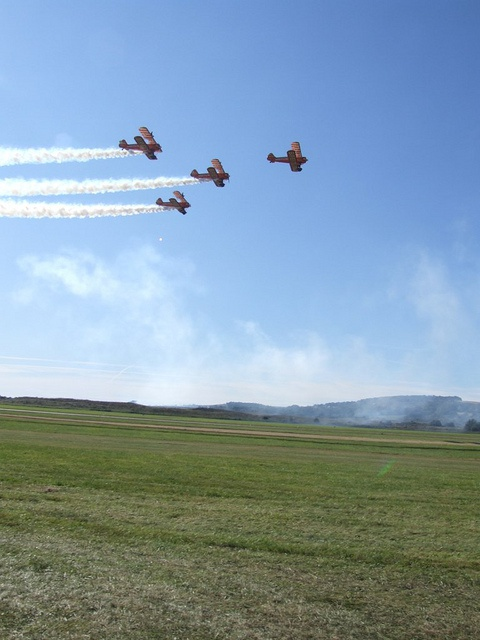Describe the objects in this image and their specific colors. I can see airplane in lightblue, gray, purple, and maroon tones, airplane in lightblue, maroon, gray, black, and brown tones, airplane in lightblue, gray, maroon, purple, and brown tones, and airplane in lightblue, gray, maroon, and purple tones in this image. 